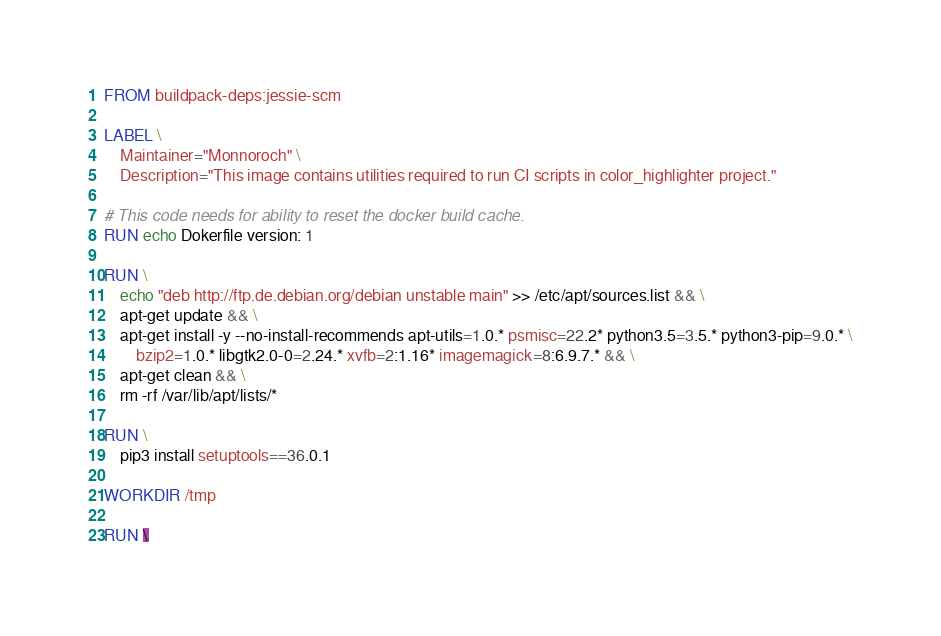Convert code to text. <code><loc_0><loc_0><loc_500><loc_500><_Dockerfile_>FROM buildpack-deps:jessie-scm

LABEL \
    Maintainer="Monnoroch" \
    Description="This image contains utilities required to run CI scripts in color_highlighter project."

# This code needs for ability to reset the docker build cache.
RUN echo Dokerfile version: 1

RUN \
    echo "deb http://ftp.de.debian.org/debian unstable main" >> /etc/apt/sources.list && \
    apt-get update && \
    apt-get install -y --no-install-recommends apt-utils=1.0.* psmisc=22.2* python3.5=3.5.* python3-pip=9.0.* \
        bzip2=1.0.* libgtk2.0-0=2.24.* xvfb=2:1.16* imagemagick=8:6.9.7.* && \
    apt-get clean && \
    rm -rf /var/lib/apt/lists/*

RUN \
    pip3 install setuptools==36.0.1

WORKDIR /tmp

RUN \</code> 